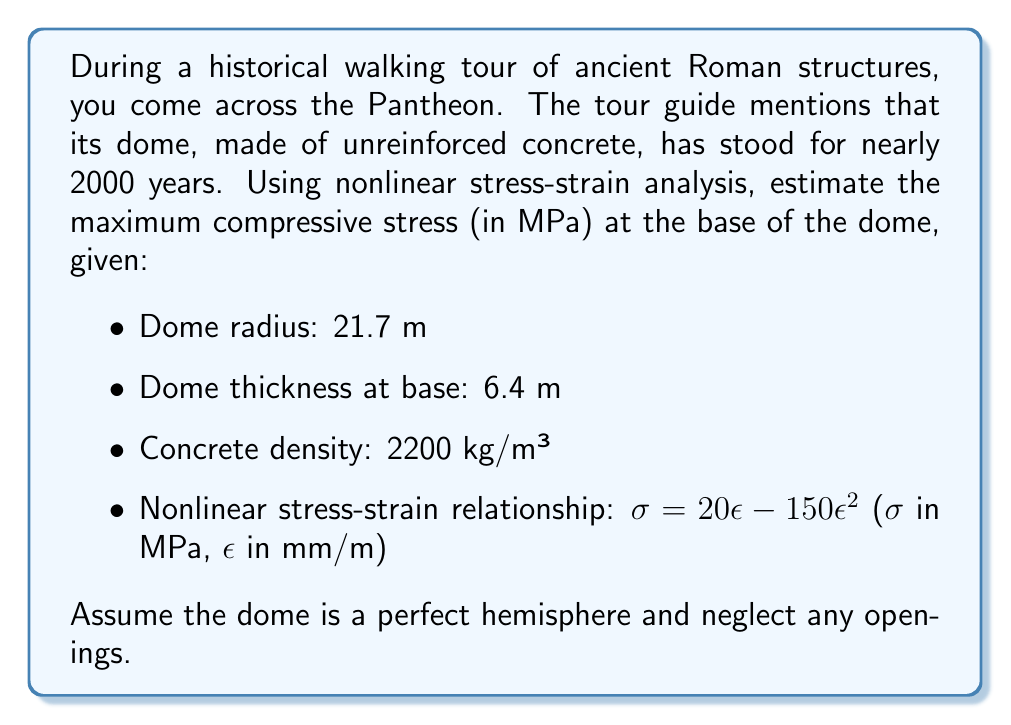Give your solution to this math problem. Let's approach this step-by-step:

1) First, we need to calculate the volume and weight of the dome:
   Volume of a hemisphere: $V = \frac{2}{3}\pi r^3$
   $V = \frac{2}{3}\pi (21.7\text{ m})^3 = 21,436\text{ m}^3$

2) The dome isn't solid, so we need to subtract the inner hemisphere:
   Inner radius = 21.7 m - 6.4 m = 15.3 m
   Inner volume = $\frac{2}{3}\pi (15.3\text{ m})^3 = 7,495\text{ m}^3$
   Actual volume = 21,436 - 7,495 = 13,941 m³

3) Calculate the weight:
   Weight = Volume × Density × g
   $W = 13,941\text{ m}^3 \times 2200\text{ kg/m}^3 \times 9.81\text{ m/s}^2 = 301,235,540\text{ N}$

4) The stress at the base is the weight divided by the area of the base ring:
   Area = $2\pi r t$ where r is the radius and t is the thickness
   $A = 2\pi \times 21.7\text{ m} \times 6.4\text{ m} = 871.8\text{ m}^2$

   Stress = $\frac{W}{A} = \frac{301,235,540\text{ N}}{871.8\text{ m}^2} = 345,538\text{ Pa} = 0.346\text{ MPa}$

5) Now we use the nonlinear stress-strain relationship:
   $\sigma = 20\epsilon - 150\epsilon^2$

   We need to solve this quadratic equation:
   $0.346 = 20\epsilon - 150\epsilon^2$
   $150\epsilon^2 - 20\epsilon + 0.346 = 0$

6) Using the quadratic formula:
   $\epsilon = \frac{20 \pm \sqrt{400 - 4 \times 150 \times 0.346}}{2 \times 150}$
   $\epsilon = 0.0174\text{ mm/m}$ or $0.1159\text{ mm/m}$

7) The smaller value is the correct solution as it represents the initial loading.

8) Now we can calculate the actual stress using this strain in the nonlinear equation:
   $\sigma = 20(0.0174) - 150(0.0174)^2 = 0.348\text{ MPa}$

This is slightly higher than the linear approximation due to the nonlinear behavior.
Answer: 0.348 MPa 